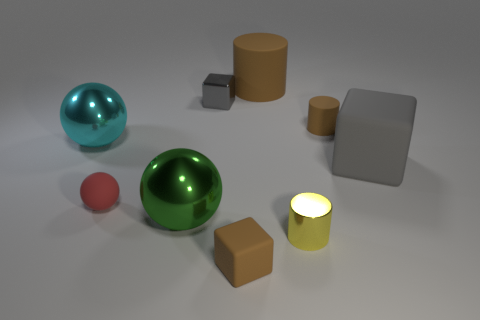What is the material of the thing that is the same color as the big matte block?
Offer a terse response. Metal. Does the small rubber cylinder have the same color as the tiny matte cube?
Your response must be concise. Yes. What is the size of the green ball?
Ensure brevity in your answer.  Large. Is the tiny brown object in front of the cyan metallic object made of the same material as the small red sphere?
Keep it short and to the point. Yes. What is the color of the big object that is the same shape as the small yellow thing?
Your answer should be compact. Brown. Do the cylinder on the left side of the tiny yellow metal cylinder and the matte sphere have the same color?
Provide a succinct answer. No. There is a metal block; are there any matte cylinders behind it?
Your response must be concise. Yes. The small thing that is both on the right side of the large brown cylinder and behind the yellow metallic cylinder is what color?
Your answer should be very brief. Brown. What shape is the large rubber object that is the same color as the tiny rubber block?
Ensure brevity in your answer.  Cylinder. What is the size of the brown cylinder that is in front of the rubber object that is behind the shiny block?
Provide a succinct answer. Small. 